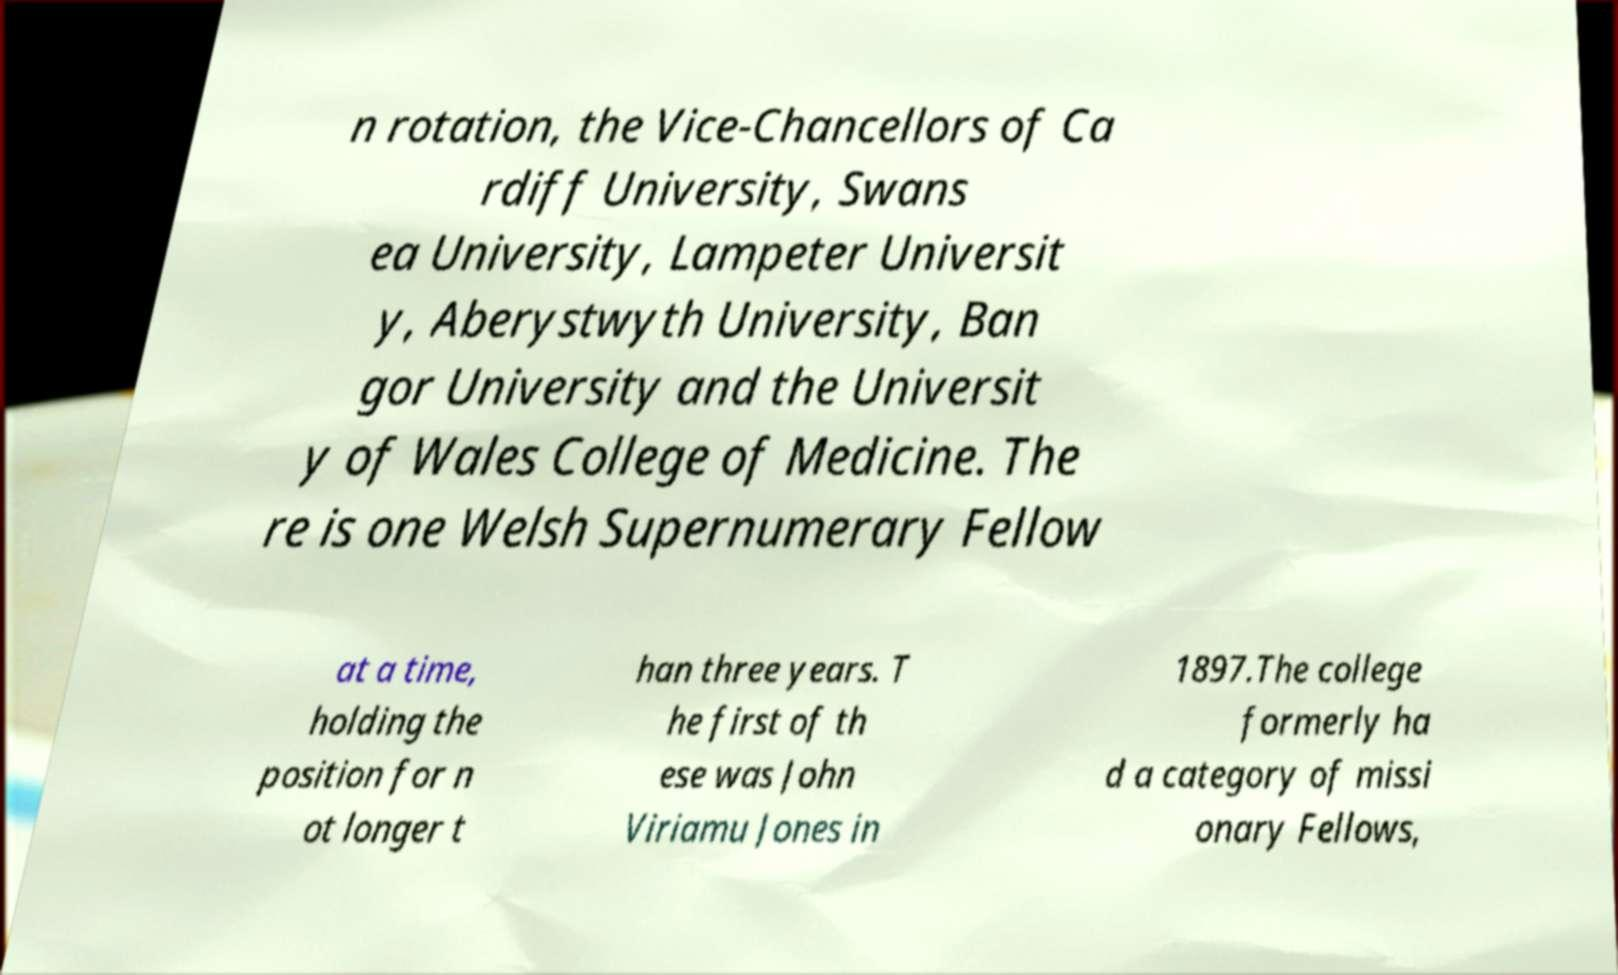There's text embedded in this image that I need extracted. Can you transcribe it verbatim? n rotation, the Vice-Chancellors of Ca rdiff University, Swans ea University, Lampeter Universit y, Aberystwyth University, Ban gor University and the Universit y of Wales College of Medicine. The re is one Welsh Supernumerary Fellow at a time, holding the position for n ot longer t han three years. T he first of th ese was John Viriamu Jones in 1897.The college formerly ha d a category of missi onary Fellows, 